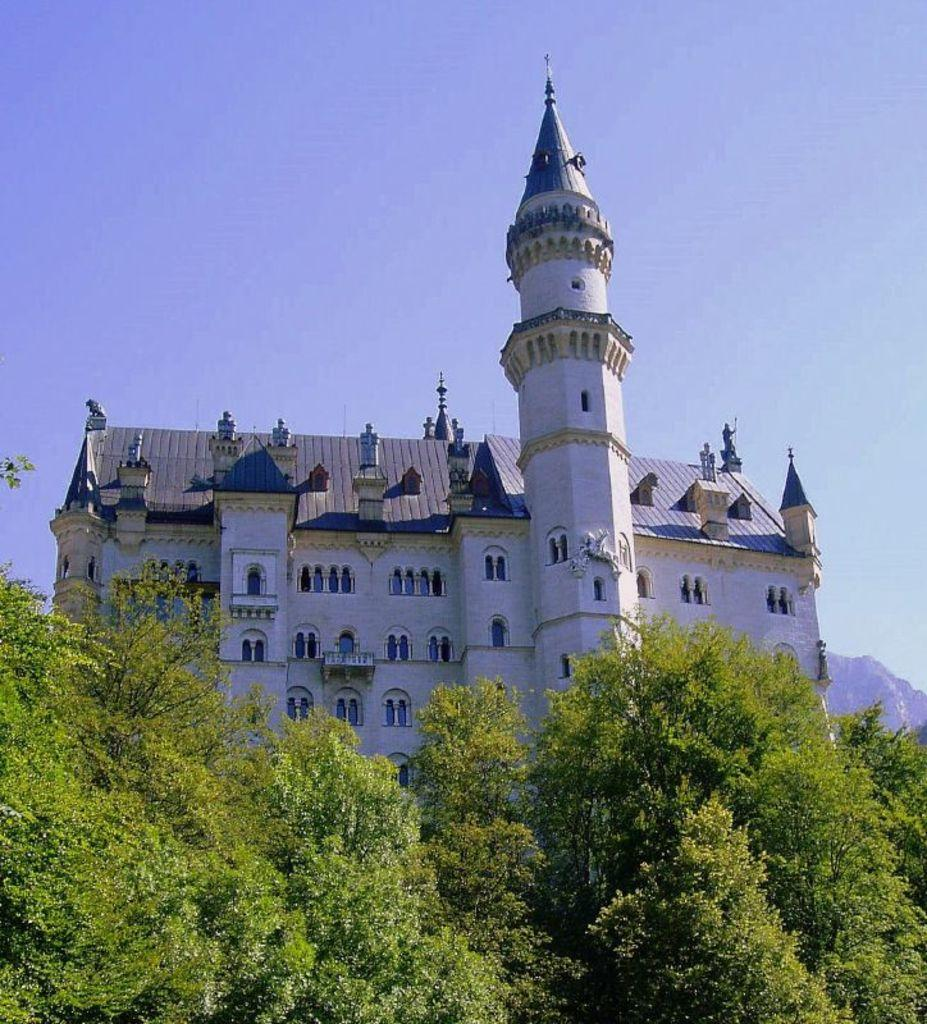What type of building is in the image? There is a white color castle house in the image. What is on top of the castle house? The castle house has a roof tile. What additional feature does the castle house have? The castle house has a tower. What can be seen in the foreground of the image? There are trees in the front bottom side of the image. What type of tooth is visible in the image? There is no tooth present in the image; it features a white color castle house with a roof tile, a tower, and trees in the foreground. 